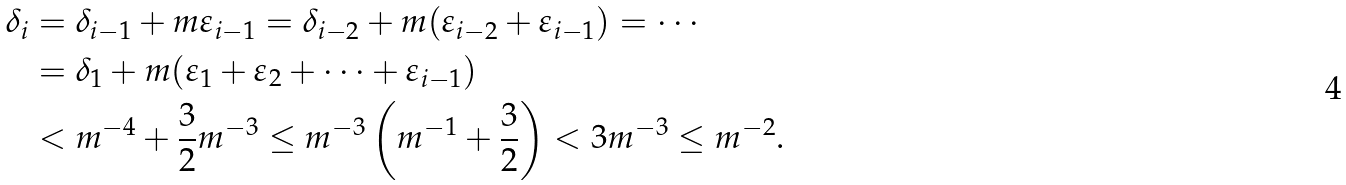<formula> <loc_0><loc_0><loc_500><loc_500>\delta _ { i } & = \delta _ { i - 1 } + m \varepsilon _ { i - 1 } = \delta _ { i - 2 } + m ( \varepsilon _ { i - 2 } + \varepsilon _ { i - 1 } ) = \cdots \\ & = \delta _ { 1 } + m ( \varepsilon _ { 1 } + \varepsilon _ { 2 } + \dots + \varepsilon _ { i - 1 } ) \\ & < m ^ { - 4 } + \frac { 3 } { 2 } m ^ { - 3 } \leq m ^ { - 3 } \left ( m ^ { - 1 } + \frac { 3 } { 2 } \right ) < 3 m ^ { - 3 } \leq m ^ { - 2 } .</formula> 